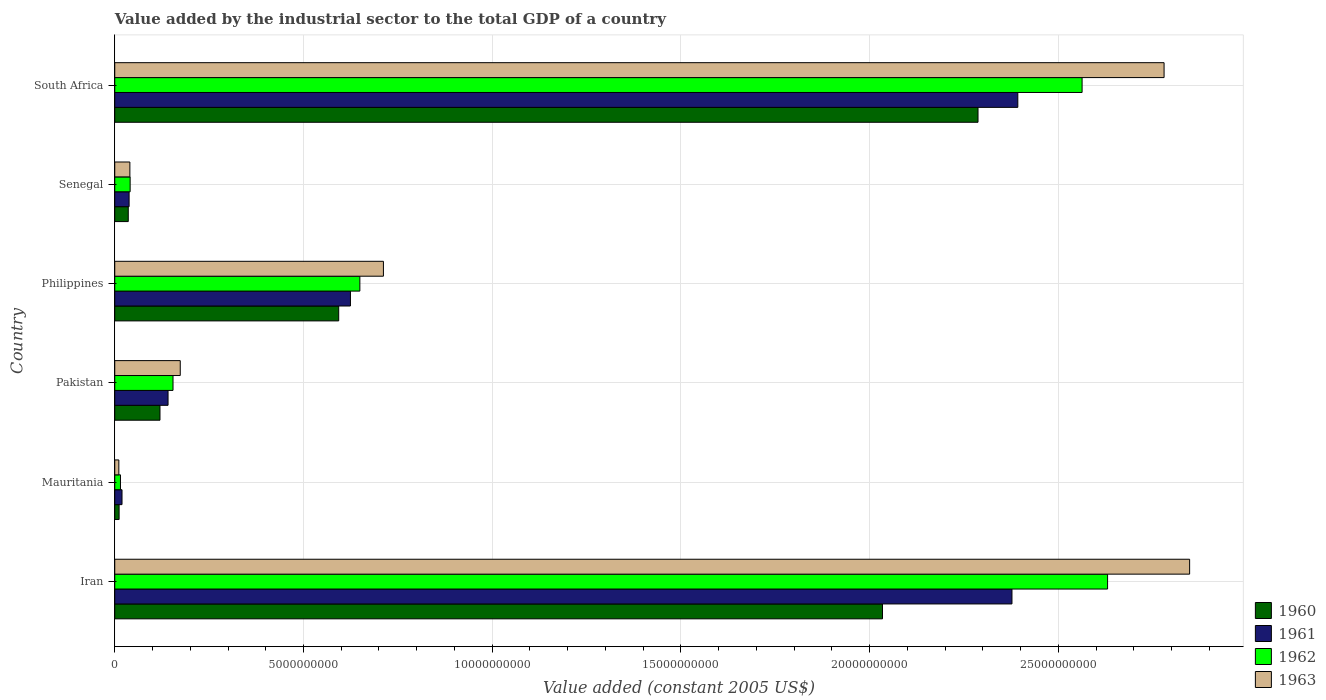How many different coloured bars are there?
Offer a terse response. 4. How many groups of bars are there?
Give a very brief answer. 6. Are the number of bars per tick equal to the number of legend labels?
Keep it short and to the point. Yes. How many bars are there on the 3rd tick from the bottom?
Your answer should be compact. 4. In how many cases, is the number of bars for a given country not equal to the number of legend labels?
Provide a succinct answer. 0. What is the value added by the industrial sector in 1962 in Philippines?
Offer a very short reply. 6.49e+09. Across all countries, what is the maximum value added by the industrial sector in 1962?
Give a very brief answer. 2.63e+1. Across all countries, what is the minimum value added by the industrial sector in 1962?
Provide a succinct answer. 1.51e+08. In which country was the value added by the industrial sector in 1963 maximum?
Offer a very short reply. Iran. In which country was the value added by the industrial sector in 1962 minimum?
Keep it short and to the point. Mauritania. What is the total value added by the industrial sector in 1961 in the graph?
Offer a very short reply. 5.59e+1. What is the difference between the value added by the industrial sector in 1962 in Senegal and that in South Africa?
Ensure brevity in your answer.  -2.52e+1. What is the difference between the value added by the industrial sector in 1960 in Mauritania and the value added by the industrial sector in 1963 in Pakistan?
Keep it short and to the point. -1.62e+09. What is the average value added by the industrial sector in 1960 per country?
Your response must be concise. 8.47e+09. What is the difference between the value added by the industrial sector in 1963 and value added by the industrial sector in 1960 in Pakistan?
Give a very brief answer. 5.37e+08. What is the ratio of the value added by the industrial sector in 1962 in Pakistan to that in Philippines?
Ensure brevity in your answer.  0.24. Is the value added by the industrial sector in 1963 in Mauritania less than that in South Africa?
Make the answer very short. Yes. What is the difference between the highest and the second highest value added by the industrial sector in 1963?
Ensure brevity in your answer.  6.77e+08. What is the difference between the highest and the lowest value added by the industrial sector in 1961?
Provide a short and direct response. 2.37e+1. In how many countries, is the value added by the industrial sector in 1961 greater than the average value added by the industrial sector in 1961 taken over all countries?
Your answer should be very brief. 2. Is it the case that in every country, the sum of the value added by the industrial sector in 1960 and value added by the industrial sector in 1961 is greater than the sum of value added by the industrial sector in 1962 and value added by the industrial sector in 1963?
Your response must be concise. No. What does the 2nd bar from the top in Senegal represents?
Ensure brevity in your answer.  1962. What does the 4th bar from the bottom in Philippines represents?
Your answer should be very brief. 1963. Is it the case that in every country, the sum of the value added by the industrial sector in 1960 and value added by the industrial sector in 1961 is greater than the value added by the industrial sector in 1963?
Your response must be concise. Yes. Are the values on the major ticks of X-axis written in scientific E-notation?
Keep it short and to the point. No. Does the graph contain any zero values?
Your answer should be very brief. No. Does the graph contain grids?
Ensure brevity in your answer.  Yes. Where does the legend appear in the graph?
Give a very brief answer. Bottom right. How many legend labels are there?
Offer a very short reply. 4. How are the legend labels stacked?
Your answer should be very brief. Vertical. What is the title of the graph?
Provide a short and direct response. Value added by the industrial sector to the total GDP of a country. What is the label or title of the X-axis?
Your answer should be compact. Value added (constant 2005 US$). What is the label or title of the Y-axis?
Offer a terse response. Country. What is the Value added (constant 2005 US$) of 1960 in Iran?
Your response must be concise. 2.03e+1. What is the Value added (constant 2005 US$) in 1961 in Iran?
Provide a succinct answer. 2.38e+1. What is the Value added (constant 2005 US$) in 1962 in Iran?
Your answer should be compact. 2.63e+1. What is the Value added (constant 2005 US$) of 1963 in Iran?
Offer a very short reply. 2.85e+1. What is the Value added (constant 2005 US$) in 1960 in Mauritania?
Your answer should be compact. 1.15e+08. What is the Value added (constant 2005 US$) in 1961 in Mauritania?
Provide a succinct answer. 1.92e+08. What is the Value added (constant 2005 US$) of 1962 in Mauritania?
Ensure brevity in your answer.  1.51e+08. What is the Value added (constant 2005 US$) of 1963 in Mauritania?
Make the answer very short. 1.08e+08. What is the Value added (constant 2005 US$) in 1960 in Pakistan?
Keep it short and to the point. 1.20e+09. What is the Value added (constant 2005 US$) in 1961 in Pakistan?
Ensure brevity in your answer.  1.41e+09. What is the Value added (constant 2005 US$) of 1962 in Pakistan?
Offer a terse response. 1.54e+09. What is the Value added (constant 2005 US$) in 1963 in Pakistan?
Offer a terse response. 1.74e+09. What is the Value added (constant 2005 US$) of 1960 in Philippines?
Offer a very short reply. 5.93e+09. What is the Value added (constant 2005 US$) in 1961 in Philippines?
Give a very brief answer. 6.24e+09. What is the Value added (constant 2005 US$) of 1962 in Philippines?
Keep it short and to the point. 6.49e+09. What is the Value added (constant 2005 US$) of 1963 in Philippines?
Provide a short and direct response. 7.12e+09. What is the Value added (constant 2005 US$) in 1960 in Senegal?
Make the answer very short. 3.58e+08. What is the Value added (constant 2005 US$) in 1961 in Senegal?
Make the answer very short. 3.80e+08. What is the Value added (constant 2005 US$) in 1962 in Senegal?
Provide a short and direct response. 4.08e+08. What is the Value added (constant 2005 US$) in 1963 in Senegal?
Your response must be concise. 4.01e+08. What is the Value added (constant 2005 US$) in 1960 in South Africa?
Your response must be concise. 2.29e+1. What is the Value added (constant 2005 US$) in 1961 in South Africa?
Provide a succinct answer. 2.39e+1. What is the Value added (constant 2005 US$) of 1962 in South Africa?
Offer a very short reply. 2.56e+1. What is the Value added (constant 2005 US$) in 1963 in South Africa?
Provide a short and direct response. 2.78e+1. Across all countries, what is the maximum Value added (constant 2005 US$) in 1960?
Provide a short and direct response. 2.29e+1. Across all countries, what is the maximum Value added (constant 2005 US$) of 1961?
Provide a succinct answer. 2.39e+1. Across all countries, what is the maximum Value added (constant 2005 US$) of 1962?
Offer a terse response. 2.63e+1. Across all countries, what is the maximum Value added (constant 2005 US$) in 1963?
Your answer should be compact. 2.85e+1. Across all countries, what is the minimum Value added (constant 2005 US$) in 1960?
Provide a short and direct response. 1.15e+08. Across all countries, what is the minimum Value added (constant 2005 US$) of 1961?
Offer a very short reply. 1.92e+08. Across all countries, what is the minimum Value added (constant 2005 US$) in 1962?
Your answer should be very brief. 1.51e+08. Across all countries, what is the minimum Value added (constant 2005 US$) in 1963?
Make the answer very short. 1.08e+08. What is the total Value added (constant 2005 US$) in 1960 in the graph?
Offer a terse response. 5.08e+1. What is the total Value added (constant 2005 US$) in 1961 in the graph?
Your response must be concise. 5.59e+1. What is the total Value added (constant 2005 US$) in 1962 in the graph?
Ensure brevity in your answer.  6.05e+1. What is the total Value added (constant 2005 US$) of 1963 in the graph?
Make the answer very short. 6.56e+1. What is the difference between the Value added (constant 2005 US$) of 1960 in Iran and that in Mauritania?
Provide a short and direct response. 2.02e+1. What is the difference between the Value added (constant 2005 US$) in 1961 in Iran and that in Mauritania?
Your answer should be compact. 2.36e+1. What is the difference between the Value added (constant 2005 US$) in 1962 in Iran and that in Mauritania?
Give a very brief answer. 2.62e+1. What is the difference between the Value added (constant 2005 US$) of 1963 in Iran and that in Mauritania?
Provide a succinct answer. 2.84e+1. What is the difference between the Value added (constant 2005 US$) in 1960 in Iran and that in Pakistan?
Give a very brief answer. 1.91e+1. What is the difference between the Value added (constant 2005 US$) in 1961 in Iran and that in Pakistan?
Offer a terse response. 2.24e+1. What is the difference between the Value added (constant 2005 US$) in 1962 in Iran and that in Pakistan?
Make the answer very short. 2.48e+1. What is the difference between the Value added (constant 2005 US$) of 1963 in Iran and that in Pakistan?
Your answer should be very brief. 2.67e+1. What is the difference between the Value added (constant 2005 US$) in 1960 in Iran and that in Philippines?
Your response must be concise. 1.44e+1. What is the difference between the Value added (constant 2005 US$) in 1961 in Iran and that in Philippines?
Give a very brief answer. 1.75e+1. What is the difference between the Value added (constant 2005 US$) of 1962 in Iran and that in Philippines?
Give a very brief answer. 1.98e+1. What is the difference between the Value added (constant 2005 US$) of 1963 in Iran and that in Philippines?
Make the answer very short. 2.14e+1. What is the difference between the Value added (constant 2005 US$) in 1960 in Iran and that in Senegal?
Your response must be concise. 2.00e+1. What is the difference between the Value added (constant 2005 US$) in 1961 in Iran and that in Senegal?
Provide a short and direct response. 2.34e+1. What is the difference between the Value added (constant 2005 US$) in 1962 in Iran and that in Senegal?
Give a very brief answer. 2.59e+1. What is the difference between the Value added (constant 2005 US$) of 1963 in Iran and that in Senegal?
Provide a short and direct response. 2.81e+1. What is the difference between the Value added (constant 2005 US$) of 1960 in Iran and that in South Africa?
Your response must be concise. -2.53e+09. What is the difference between the Value added (constant 2005 US$) of 1961 in Iran and that in South Africa?
Ensure brevity in your answer.  -1.55e+08. What is the difference between the Value added (constant 2005 US$) in 1962 in Iran and that in South Africa?
Provide a short and direct response. 6.75e+08. What is the difference between the Value added (constant 2005 US$) in 1963 in Iran and that in South Africa?
Ensure brevity in your answer.  6.77e+08. What is the difference between the Value added (constant 2005 US$) in 1960 in Mauritania and that in Pakistan?
Give a very brief answer. -1.08e+09. What is the difference between the Value added (constant 2005 US$) of 1961 in Mauritania and that in Pakistan?
Offer a very short reply. -1.22e+09. What is the difference between the Value added (constant 2005 US$) in 1962 in Mauritania and that in Pakistan?
Provide a short and direct response. -1.39e+09. What is the difference between the Value added (constant 2005 US$) of 1963 in Mauritania and that in Pakistan?
Provide a succinct answer. -1.63e+09. What is the difference between the Value added (constant 2005 US$) in 1960 in Mauritania and that in Philippines?
Give a very brief answer. -5.82e+09. What is the difference between the Value added (constant 2005 US$) in 1961 in Mauritania and that in Philippines?
Give a very brief answer. -6.05e+09. What is the difference between the Value added (constant 2005 US$) of 1962 in Mauritania and that in Philippines?
Keep it short and to the point. -6.34e+09. What is the difference between the Value added (constant 2005 US$) of 1963 in Mauritania and that in Philippines?
Provide a short and direct response. -7.01e+09. What is the difference between the Value added (constant 2005 US$) of 1960 in Mauritania and that in Senegal?
Offer a very short reply. -2.42e+08. What is the difference between the Value added (constant 2005 US$) in 1961 in Mauritania and that in Senegal?
Give a very brief answer. -1.88e+08. What is the difference between the Value added (constant 2005 US$) in 1962 in Mauritania and that in Senegal?
Offer a very short reply. -2.56e+08. What is the difference between the Value added (constant 2005 US$) of 1963 in Mauritania and that in Senegal?
Your response must be concise. -2.92e+08. What is the difference between the Value added (constant 2005 US$) in 1960 in Mauritania and that in South Africa?
Offer a very short reply. -2.28e+1. What is the difference between the Value added (constant 2005 US$) of 1961 in Mauritania and that in South Africa?
Keep it short and to the point. -2.37e+1. What is the difference between the Value added (constant 2005 US$) of 1962 in Mauritania and that in South Africa?
Your answer should be compact. -2.55e+1. What is the difference between the Value added (constant 2005 US$) in 1963 in Mauritania and that in South Africa?
Ensure brevity in your answer.  -2.77e+1. What is the difference between the Value added (constant 2005 US$) in 1960 in Pakistan and that in Philippines?
Your answer should be very brief. -4.73e+09. What is the difference between the Value added (constant 2005 US$) of 1961 in Pakistan and that in Philippines?
Give a very brief answer. -4.83e+09. What is the difference between the Value added (constant 2005 US$) of 1962 in Pakistan and that in Philippines?
Ensure brevity in your answer.  -4.95e+09. What is the difference between the Value added (constant 2005 US$) in 1963 in Pakistan and that in Philippines?
Give a very brief answer. -5.38e+09. What is the difference between the Value added (constant 2005 US$) in 1960 in Pakistan and that in Senegal?
Your answer should be compact. 8.40e+08. What is the difference between the Value added (constant 2005 US$) in 1961 in Pakistan and that in Senegal?
Your answer should be compact. 1.03e+09. What is the difference between the Value added (constant 2005 US$) in 1962 in Pakistan and that in Senegal?
Your answer should be very brief. 1.14e+09. What is the difference between the Value added (constant 2005 US$) of 1963 in Pakistan and that in Senegal?
Offer a very short reply. 1.33e+09. What is the difference between the Value added (constant 2005 US$) of 1960 in Pakistan and that in South Africa?
Offer a very short reply. -2.17e+1. What is the difference between the Value added (constant 2005 US$) in 1961 in Pakistan and that in South Africa?
Your answer should be compact. -2.25e+1. What is the difference between the Value added (constant 2005 US$) in 1962 in Pakistan and that in South Africa?
Offer a terse response. -2.41e+1. What is the difference between the Value added (constant 2005 US$) in 1963 in Pakistan and that in South Africa?
Ensure brevity in your answer.  -2.61e+1. What is the difference between the Value added (constant 2005 US$) of 1960 in Philippines and that in Senegal?
Give a very brief answer. 5.57e+09. What is the difference between the Value added (constant 2005 US$) of 1961 in Philippines and that in Senegal?
Make the answer very short. 5.86e+09. What is the difference between the Value added (constant 2005 US$) of 1962 in Philippines and that in Senegal?
Your response must be concise. 6.09e+09. What is the difference between the Value added (constant 2005 US$) of 1963 in Philippines and that in Senegal?
Your response must be concise. 6.72e+09. What is the difference between the Value added (constant 2005 US$) of 1960 in Philippines and that in South Africa?
Your answer should be very brief. -1.69e+1. What is the difference between the Value added (constant 2005 US$) of 1961 in Philippines and that in South Africa?
Give a very brief answer. -1.77e+1. What is the difference between the Value added (constant 2005 US$) of 1962 in Philippines and that in South Africa?
Give a very brief answer. -1.91e+1. What is the difference between the Value added (constant 2005 US$) of 1963 in Philippines and that in South Africa?
Provide a succinct answer. -2.07e+1. What is the difference between the Value added (constant 2005 US$) in 1960 in Senegal and that in South Africa?
Give a very brief answer. -2.25e+1. What is the difference between the Value added (constant 2005 US$) in 1961 in Senegal and that in South Africa?
Make the answer very short. -2.35e+1. What is the difference between the Value added (constant 2005 US$) in 1962 in Senegal and that in South Africa?
Your answer should be compact. -2.52e+1. What is the difference between the Value added (constant 2005 US$) in 1963 in Senegal and that in South Africa?
Your answer should be very brief. -2.74e+1. What is the difference between the Value added (constant 2005 US$) in 1960 in Iran and the Value added (constant 2005 US$) in 1961 in Mauritania?
Keep it short and to the point. 2.01e+1. What is the difference between the Value added (constant 2005 US$) of 1960 in Iran and the Value added (constant 2005 US$) of 1962 in Mauritania?
Make the answer very short. 2.02e+1. What is the difference between the Value added (constant 2005 US$) in 1960 in Iran and the Value added (constant 2005 US$) in 1963 in Mauritania?
Make the answer very short. 2.02e+1. What is the difference between the Value added (constant 2005 US$) of 1961 in Iran and the Value added (constant 2005 US$) of 1962 in Mauritania?
Ensure brevity in your answer.  2.36e+1. What is the difference between the Value added (constant 2005 US$) in 1961 in Iran and the Value added (constant 2005 US$) in 1963 in Mauritania?
Make the answer very short. 2.37e+1. What is the difference between the Value added (constant 2005 US$) in 1962 in Iran and the Value added (constant 2005 US$) in 1963 in Mauritania?
Make the answer very short. 2.62e+1. What is the difference between the Value added (constant 2005 US$) in 1960 in Iran and the Value added (constant 2005 US$) in 1961 in Pakistan?
Make the answer very short. 1.89e+1. What is the difference between the Value added (constant 2005 US$) of 1960 in Iran and the Value added (constant 2005 US$) of 1962 in Pakistan?
Your answer should be very brief. 1.88e+1. What is the difference between the Value added (constant 2005 US$) of 1960 in Iran and the Value added (constant 2005 US$) of 1963 in Pakistan?
Provide a short and direct response. 1.86e+1. What is the difference between the Value added (constant 2005 US$) in 1961 in Iran and the Value added (constant 2005 US$) in 1962 in Pakistan?
Your answer should be very brief. 2.22e+1. What is the difference between the Value added (constant 2005 US$) in 1961 in Iran and the Value added (constant 2005 US$) in 1963 in Pakistan?
Provide a short and direct response. 2.20e+1. What is the difference between the Value added (constant 2005 US$) of 1962 in Iran and the Value added (constant 2005 US$) of 1963 in Pakistan?
Provide a short and direct response. 2.46e+1. What is the difference between the Value added (constant 2005 US$) of 1960 in Iran and the Value added (constant 2005 US$) of 1961 in Philippines?
Provide a short and direct response. 1.41e+1. What is the difference between the Value added (constant 2005 US$) in 1960 in Iran and the Value added (constant 2005 US$) in 1962 in Philippines?
Offer a terse response. 1.38e+1. What is the difference between the Value added (constant 2005 US$) of 1960 in Iran and the Value added (constant 2005 US$) of 1963 in Philippines?
Offer a very short reply. 1.32e+1. What is the difference between the Value added (constant 2005 US$) in 1961 in Iran and the Value added (constant 2005 US$) in 1962 in Philippines?
Your answer should be very brief. 1.73e+1. What is the difference between the Value added (constant 2005 US$) of 1961 in Iran and the Value added (constant 2005 US$) of 1963 in Philippines?
Offer a terse response. 1.67e+1. What is the difference between the Value added (constant 2005 US$) of 1962 in Iran and the Value added (constant 2005 US$) of 1963 in Philippines?
Provide a short and direct response. 1.92e+1. What is the difference between the Value added (constant 2005 US$) in 1960 in Iran and the Value added (constant 2005 US$) in 1961 in Senegal?
Your answer should be very brief. 2.00e+1. What is the difference between the Value added (constant 2005 US$) in 1960 in Iran and the Value added (constant 2005 US$) in 1962 in Senegal?
Make the answer very short. 1.99e+1. What is the difference between the Value added (constant 2005 US$) of 1960 in Iran and the Value added (constant 2005 US$) of 1963 in Senegal?
Offer a terse response. 1.99e+1. What is the difference between the Value added (constant 2005 US$) in 1961 in Iran and the Value added (constant 2005 US$) in 1962 in Senegal?
Your answer should be very brief. 2.34e+1. What is the difference between the Value added (constant 2005 US$) in 1961 in Iran and the Value added (constant 2005 US$) in 1963 in Senegal?
Offer a terse response. 2.34e+1. What is the difference between the Value added (constant 2005 US$) in 1962 in Iran and the Value added (constant 2005 US$) in 1963 in Senegal?
Your answer should be compact. 2.59e+1. What is the difference between the Value added (constant 2005 US$) in 1960 in Iran and the Value added (constant 2005 US$) in 1961 in South Africa?
Your answer should be very brief. -3.58e+09. What is the difference between the Value added (constant 2005 US$) of 1960 in Iran and the Value added (constant 2005 US$) of 1962 in South Africa?
Ensure brevity in your answer.  -5.29e+09. What is the difference between the Value added (constant 2005 US$) of 1960 in Iran and the Value added (constant 2005 US$) of 1963 in South Africa?
Offer a very short reply. -7.46e+09. What is the difference between the Value added (constant 2005 US$) of 1961 in Iran and the Value added (constant 2005 US$) of 1962 in South Africa?
Provide a succinct answer. -1.86e+09. What is the difference between the Value added (constant 2005 US$) of 1961 in Iran and the Value added (constant 2005 US$) of 1963 in South Africa?
Your answer should be compact. -4.03e+09. What is the difference between the Value added (constant 2005 US$) of 1962 in Iran and the Value added (constant 2005 US$) of 1963 in South Africa?
Keep it short and to the point. -1.50e+09. What is the difference between the Value added (constant 2005 US$) of 1960 in Mauritania and the Value added (constant 2005 US$) of 1961 in Pakistan?
Provide a short and direct response. -1.30e+09. What is the difference between the Value added (constant 2005 US$) of 1960 in Mauritania and the Value added (constant 2005 US$) of 1962 in Pakistan?
Provide a short and direct response. -1.43e+09. What is the difference between the Value added (constant 2005 US$) of 1960 in Mauritania and the Value added (constant 2005 US$) of 1963 in Pakistan?
Your answer should be compact. -1.62e+09. What is the difference between the Value added (constant 2005 US$) in 1961 in Mauritania and the Value added (constant 2005 US$) in 1962 in Pakistan?
Make the answer very short. -1.35e+09. What is the difference between the Value added (constant 2005 US$) of 1961 in Mauritania and the Value added (constant 2005 US$) of 1963 in Pakistan?
Your answer should be very brief. -1.54e+09. What is the difference between the Value added (constant 2005 US$) in 1962 in Mauritania and the Value added (constant 2005 US$) in 1963 in Pakistan?
Your answer should be very brief. -1.58e+09. What is the difference between the Value added (constant 2005 US$) of 1960 in Mauritania and the Value added (constant 2005 US$) of 1961 in Philippines?
Your answer should be compact. -6.13e+09. What is the difference between the Value added (constant 2005 US$) of 1960 in Mauritania and the Value added (constant 2005 US$) of 1962 in Philippines?
Your answer should be very brief. -6.38e+09. What is the difference between the Value added (constant 2005 US$) in 1960 in Mauritania and the Value added (constant 2005 US$) in 1963 in Philippines?
Offer a terse response. -7.00e+09. What is the difference between the Value added (constant 2005 US$) of 1961 in Mauritania and the Value added (constant 2005 US$) of 1962 in Philippines?
Ensure brevity in your answer.  -6.30e+09. What is the difference between the Value added (constant 2005 US$) in 1961 in Mauritania and the Value added (constant 2005 US$) in 1963 in Philippines?
Make the answer very short. -6.93e+09. What is the difference between the Value added (constant 2005 US$) in 1962 in Mauritania and the Value added (constant 2005 US$) in 1963 in Philippines?
Provide a short and direct response. -6.97e+09. What is the difference between the Value added (constant 2005 US$) in 1960 in Mauritania and the Value added (constant 2005 US$) in 1961 in Senegal?
Provide a short and direct response. -2.65e+08. What is the difference between the Value added (constant 2005 US$) of 1960 in Mauritania and the Value added (constant 2005 US$) of 1962 in Senegal?
Ensure brevity in your answer.  -2.92e+08. What is the difference between the Value added (constant 2005 US$) of 1960 in Mauritania and the Value added (constant 2005 US$) of 1963 in Senegal?
Offer a very short reply. -2.85e+08. What is the difference between the Value added (constant 2005 US$) in 1961 in Mauritania and the Value added (constant 2005 US$) in 1962 in Senegal?
Your answer should be very brief. -2.15e+08. What is the difference between the Value added (constant 2005 US$) of 1961 in Mauritania and the Value added (constant 2005 US$) of 1963 in Senegal?
Your answer should be compact. -2.08e+08. What is the difference between the Value added (constant 2005 US$) of 1962 in Mauritania and the Value added (constant 2005 US$) of 1963 in Senegal?
Provide a short and direct response. -2.49e+08. What is the difference between the Value added (constant 2005 US$) in 1960 in Mauritania and the Value added (constant 2005 US$) in 1961 in South Africa?
Offer a terse response. -2.38e+1. What is the difference between the Value added (constant 2005 US$) in 1960 in Mauritania and the Value added (constant 2005 US$) in 1962 in South Africa?
Ensure brevity in your answer.  -2.55e+1. What is the difference between the Value added (constant 2005 US$) of 1960 in Mauritania and the Value added (constant 2005 US$) of 1963 in South Africa?
Your answer should be compact. -2.77e+1. What is the difference between the Value added (constant 2005 US$) in 1961 in Mauritania and the Value added (constant 2005 US$) in 1962 in South Africa?
Keep it short and to the point. -2.54e+1. What is the difference between the Value added (constant 2005 US$) of 1961 in Mauritania and the Value added (constant 2005 US$) of 1963 in South Africa?
Make the answer very short. -2.76e+1. What is the difference between the Value added (constant 2005 US$) in 1962 in Mauritania and the Value added (constant 2005 US$) in 1963 in South Africa?
Ensure brevity in your answer.  -2.76e+1. What is the difference between the Value added (constant 2005 US$) of 1960 in Pakistan and the Value added (constant 2005 US$) of 1961 in Philippines?
Ensure brevity in your answer.  -5.05e+09. What is the difference between the Value added (constant 2005 US$) of 1960 in Pakistan and the Value added (constant 2005 US$) of 1962 in Philippines?
Ensure brevity in your answer.  -5.30e+09. What is the difference between the Value added (constant 2005 US$) of 1960 in Pakistan and the Value added (constant 2005 US$) of 1963 in Philippines?
Offer a very short reply. -5.92e+09. What is the difference between the Value added (constant 2005 US$) in 1961 in Pakistan and the Value added (constant 2005 US$) in 1962 in Philippines?
Make the answer very short. -5.08e+09. What is the difference between the Value added (constant 2005 US$) of 1961 in Pakistan and the Value added (constant 2005 US$) of 1963 in Philippines?
Provide a succinct answer. -5.71e+09. What is the difference between the Value added (constant 2005 US$) of 1962 in Pakistan and the Value added (constant 2005 US$) of 1963 in Philippines?
Your answer should be very brief. -5.57e+09. What is the difference between the Value added (constant 2005 US$) of 1960 in Pakistan and the Value added (constant 2005 US$) of 1961 in Senegal?
Your answer should be very brief. 8.18e+08. What is the difference between the Value added (constant 2005 US$) in 1960 in Pakistan and the Value added (constant 2005 US$) in 1962 in Senegal?
Give a very brief answer. 7.91e+08. What is the difference between the Value added (constant 2005 US$) of 1960 in Pakistan and the Value added (constant 2005 US$) of 1963 in Senegal?
Give a very brief answer. 7.98e+08. What is the difference between the Value added (constant 2005 US$) in 1961 in Pakistan and the Value added (constant 2005 US$) in 1962 in Senegal?
Make the answer very short. 1.00e+09. What is the difference between the Value added (constant 2005 US$) of 1961 in Pakistan and the Value added (constant 2005 US$) of 1963 in Senegal?
Keep it short and to the point. 1.01e+09. What is the difference between the Value added (constant 2005 US$) of 1962 in Pakistan and the Value added (constant 2005 US$) of 1963 in Senegal?
Your answer should be very brief. 1.14e+09. What is the difference between the Value added (constant 2005 US$) of 1960 in Pakistan and the Value added (constant 2005 US$) of 1961 in South Africa?
Offer a very short reply. -2.27e+1. What is the difference between the Value added (constant 2005 US$) in 1960 in Pakistan and the Value added (constant 2005 US$) in 1962 in South Africa?
Give a very brief answer. -2.44e+1. What is the difference between the Value added (constant 2005 US$) of 1960 in Pakistan and the Value added (constant 2005 US$) of 1963 in South Africa?
Provide a succinct answer. -2.66e+1. What is the difference between the Value added (constant 2005 US$) of 1961 in Pakistan and the Value added (constant 2005 US$) of 1962 in South Africa?
Your answer should be very brief. -2.42e+1. What is the difference between the Value added (constant 2005 US$) of 1961 in Pakistan and the Value added (constant 2005 US$) of 1963 in South Africa?
Your answer should be very brief. -2.64e+1. What is the difference between the Value added (constant 2005 US$) in 1962 in Pakistan and the Value added (constant 2005 US$) in 1963 in South Africa?
Offer a very short reply. -2.63e+1. What is the difference between the Value added (constant 2005 US$) in 1960 in Philippines and the Value added (constant 2005 US$) in 1961 in Senegal?
Make the answer very short. 5.55e+09. What is the difference between the Value added (constant 2005 US$) of 1960 in Philippines and the Value added (constant 2005 US$) of 1962 in Senegal?
Keep it short and to the point. 5.53e+09. What is the difference between the Value added (constant 2005 US$) of 1960 in Philippines and the Value added (constant 2005 US$) of 1963 in Senegal?
Make the answer very short. 5.53e+09. What is the difference between the Value added (constant 2005 US$) in 1961 in Philippines and the Value added (constant 2005 US$) in 1962 in Senegal?
Your answer should be very brief. 5.84e+09. What is the difference between the Value added (constant 2005 US$) in 1961 in Philippines and the Value added (constant 2005 US$) in 1963 in Senegal?
Make the answer very short. 5.84e+09. What is the difference between the Value added (constant 2005 US$) of 1962 in Philippines and the Value added (constant 2005 US$) of 1963 in Senegal?
Keep it short and to the point. 6.09e+09. What is the difference between the Value added (constant 2005 US$) in 1960 in Philippines and the Value added (constant 2005 US$) in 1961 in South Africa?
Your response must be concise. -1.80e+1. What is the difference between the Value added (constant 2005 US$) of 1960 in Philippines and the Value added (constant 2005 US$) of 1962 in South Africa?
Make the answer very short. -1.97e+1. What is the difference between the Value added (constant 2005 US$) in 1960 in Philippines and the Value added (constant 2005 US$) in 1963 in South Africa?
Provide a succinct answer. -2.19e+1. What is the difference between the Value added (constant 2005 US$) in 1961 in Philippines and the Value added (constant 2005 US$) in 1962 in South Africa?
Offer a very short reply. -1.94e+1. What is the difference between the Value added (constant 2005 US$) in 1961 in Philippines and the Value added (constant 2005 US$) in 1963 in South Africa?
Give a very brief answer. -2.16e+1. What is the difference between the Value added (constant 2005 US$) of 1962 in Philippines and the Value added (constant 2005 US$) of 1963 in South Africa?
Provide a succinct answer. -2.13e+1. What is the difference between the Value added (constant 2005 US$) in 1960 in Senegal and the Value added (constant 2005 US$) in 1961 in South Africa?
Offer a very short reply. -2.36e+1. What is the difference between the Value added (constant 2005 US$) in 1960 in Senegal and the Value added (constant 2005 US$) in 1962 in South Africa?
Your answer should be very brief. -2.53e+1. What is the difference between the Value added (constant 2005 US$) in 1960 in Senegal and the Value added (constant 2005 US$) in 1963 in South Africa?
Offer a terse response. -2.74e+1. What is the difference between the Value added (constant 2005 US$) in 1961 in Senegal and the Value added (constant 2005 US$) in 1962 in South Africa?
Give a very brief answer. -2.52e+1. What is the difference between the Value added (constant 2005 US$) of 1961 in Senegal and the Value added (constant 2005 US$) of 1963 in South Africa?
Offer a very short reply. -2.74e+1. What is the difference between the Value added (constant 2005 US$) in 1962 in Senegal and the Value added (constant 2005 US$) in 1963 in South Africa?
Offer a terse response. -2.74e+1. What is the average Value added (constant 2005 US$) in 1960 per country?
Offer a terse response. 8.47e+09. What is the average Value added (constant 2005 US$) in 1961 per country?
Ensure brevity in your answer.  9.32e+09. What is the average Value added (constant 2005 US$) in 1962 per country?
Keep it short and to the point. 1.01e+1. What is the average Value added (constant 2005 US$) in 1963 per country?
Give a very brief answer. 1.09e+1. What is the difference between the Value added (constant 2005 US$) in 1960 and Value added (constant 2005 US$) in 1961 in Iran?
Provide a short and direct response. -3.43e+09. What is the difference between the Value added (constant 2005 US$) of 1960 and Value added (constant 2005 US$) of 1962 in Iran?
Keep it short and to the point. -5.96e+09. What is the difference between the Value added (constant 2005 US$) of 1960 and Value added (constant 2005 US$) of 1963 in Iran?
Offer a very short reply. -8.14e+09. What is the difference between the Value added (constant 2005 US$) of 1961 and Value added (constant 2005 US$) of 1962 in Iran?
Offer a terse response. -2.53e+09. What is the difference between the Value added (constant 2005 US$) in 1961 and Value added (constant 2005 US$) in 1963 in Iran?
Offer a very short reply. -4.71e+09. What is the difference between the Value added (constant 2005 US$) of 1962 and Value added (constant 2005 US$) of 1963 in Iran?
Provide a succinct answer. -2.17e+09. What is the difference between the Value added (constant 2005 US$) in 1960 and Value added (constant 2005 US$) in 1961 in Mauritania?
Your answer should be compact. -7.68e+07. What is the difference between the Value added (constant 2005 US$) in 1960 and Value added (constant 2005 US$) in 1962 in Mauritania?
Your answer should be very brief. -3.59e+07. What is the difference between the Value added (constant 2005 US$) of 1960 and Value added (constant 2005 US$) of 1963 in Mauritania?
Make the answer very short. 7.13e+06. What is the difference between the Value added (constant 2005 US$) of 1961 and Value added (constant 2005 US$) of 1962 in Mauritania?
Keep it short and to the point. 4.09e+07. What is the difference between the Value added (constant 2005 US$) in 1961 and Value added (constant 2005 US$) in 1963 in Mauritania?
Offer a very short reply. 8.39e+07. What is the difference between the Value added (constant 2005 US$) in 1962 and Value added (constant 2005 US$) in 1963 in Mauritania?
Make the answer very short. 4.31e+07. What is the difference between the Value added (constant 2005 US$) in 1960 and Value added (constant 2005 US$) in 1961 in Pakistan?
Provide a short and direct response. -2.14e+08. What is the difference between the Value added (constant 2005 US$) in 1960 and Value added (constant 2005 US$) in 1962 in Pakistan?
Provide a short and direct response. -3.45e+08. What is the difference between the Value added (constant 2005 US$) of 1960 and Value added (constant 2005 US$) of 1963 in Pakistan?
Your response must be concise. -5.37e+08. What is the difference between the Value added (constant 2005 US$) in 1961 and Value added (constant 2005 US$) in 1962 in Pakistan?
Provide a short and direct response. -1.32e+08. What is the difference between the Value added (constant 2005 US$) in 1961 and Value added (constant 2005 US$) in 1963 in Pakistan?
Your answer should be very brief. -3.23e+08. What is the difference between the Value added (constant 2005 US$) in 1962 and Value added (constant 2005 US$) in 1963 in Pakistan?
Offer a terse response. -1.92e+08. What is the difference between the Value added (constant 2005 US$) in 1960 and Value added (constant 2005 US$) in 1961 in Philippines?
Offer a terse response. -3.11e+08. What is the difference between the Value added (constant 2005 US$) in 1960 and Value added (constant 2005 US$) in 1962 in Philippines?
Your answer should be very brief. -5.61e+08. What is the difference between the Value added (constant 2005 US$) of 1960 and Value added (constant 2005 US$) of 1963 in Philippines?
Keep it short and to the point. -1.18e+09. What is the difference between the Value added (constant 2005 US$) of 1961 and Value added (constant 2005 US$) of 1962 in Philippines?
Provide a short and direct response. -2.50e+08. What is the difference between the Value added (constant 2005 US$) in 1961 and Value added (constant 2005 US$) in 1963 in Philippines?
Offer a terse response. -8.74e+08. What is the difference between the Value added (constant 2005 US$) of 1962 and Value added (constant 2005 US$) of 1963 in Philippines?
Provide a succinct answer. -6.24e+08. What is the difference between the Value added (constant 2005 US$) in 1960 and Value added (constant 2005 US$) in 1961 in Senegal?
Your answer should be very brief. -2.25e+07. What is the difference between the Value added (constant 2005 US$) of 1960 and Value added (constant 2005 US$) of 1962 in Senegal?
Keep it short and to the point. -4.98e+07. What is the difference between the Value added (constant 2005 US$) of 1960 and Value added (constant 2005 US$) of 1963 in Senegal?
Provide a succinct answer. -4.27e+07. What is the difference between the Value added (constant 2005 US$) of 1961 and Value added (constant 2005 US$) of 1962 in Senegal?
Provide a short and direct response. -2.72e+07. What is the difference between the Value added (constant 2005 US$) in 1961 and Value added (constant 2005 US$) in 1963 in Senegal?
Your answer should be very brief. -2.02e+07. What is the difference between the Value added (constant 2005 US$) of 1962 and Value added (constant 2005 US$) of 1963 in Senegal?
Keep it short and to the point. 7.03e+06. What is the difference between the Value added (constant 2005 US$) of 1960 and Value added (constant 2005 US$) of 1961 in South Africa?
Provide a succinct answer. -1.05e+09. What is the difference between the Value added (constant 2005 US$) in 1960 and Value added (constant 2005 US$) in 1962 in South Africa?
Make the answer very short. -2.76e+09. What is the difference between the Value added (constant 2005 US$) in 1960 and Value added (constant 2005 US$) in 1963 in South Africa?
Your response must be concise. -4.93e+09. What is the difference between the Value added (constant 2005 US$) of 1961 and Value added (constant 2005 US$) of 1962 in South Africa?
Your answer should be compact. -1.70e+09. What is the difference between the Value added (constant 2005 US$) in 1961 and Value added (constant 2005 US$) in 1963 in South Africa?
Your answer should be compact. -3.87e+09. What is the difference between the Value added (constant 2005 US$) of 1962 and Value added (constant 2005 US$) of 1963 in South Africa?
Keep it short and to the point. -2.17e+09. What is the ratio of the Value added (constant 2005 US$) in 1960 in Iran to that in Mauritania?
Give a very brief answer. 176.32. What is the ratio of the Value added (constant 2005 US$) in 1961 in Iran to that in Mauritania?
Offer a very short reply. 123.7. What is the ratio of the Value added (constant 2005 US$) in 1962 in Iran to that in Mauritania?
Your answer should be compact. 173.84. What is the ratio of the Value added (constant 2005 US$) of 1963 in Iran to that in Mauritania?
Your answer should be compact. 263.11. What is the ratio of the Value added (constant 2005 US$) in 1960 in Iran to that in Pakistan?
Keep it short and to the point. 16.98. What is the ratio of the Value added (constant 2005 US$) of 1961 in Iran to that in Pakistan?
Keep it short and to the point. 16.84. What is the ratio of the Value added (constant 2005 US$) of 1962 in Iran to that in Pakistan?
Give a very brief answer. 17.04. What is the ratio of the Value added (constant 2005 US$) in 1963 in Iran to that in Pakistan?
Offer a terse response. 16.41. What is the ratio of the Value added (constant 2005 US$) in 1960 in Iran to that in Philippines?
Provide a short and direct response. 3.43. What is the ratio of the Value added (constant 2005 US$) in 1961 in Iran to that in Philippines?
Give a very brief answer. 3.81. What is the ratio of the Value added (constant 2005 US$) of 1962 in Iran to that in Philippines?
Keep it short and to the point. 4.05. What is the ratio of the Value added (constant 2005 US$) of 1963 in Iran to that in Philippines?
Give a very brief answer. 4. What is the ratio of the Value added (constant 2005 US$) in 1960 in Iran to that in Senegal?
Offer a very short reply. 56.85. What is the ratio of the Value added (constant 2005 US$) in 1961 in Iran to that in Senegal?
Give a very brief answer. 62.5. What is the ratio of the Value added (constant 2005 US$) in 1962 in Iran to that in Senegal?
Give a very brief answer. 64.54. What is the ratio of the Value added (constant 2005 US$) in 1963 in Iran to that in Senegal?
Provide a short and direct response. 71.1. What is the ratio of the Value added (constant 2005 US$) in 1960 in Iran to that in South Africa?
Give a very brief answer. 0.89. What is the ratio of the Value added (constant 2005 US$) in 1961 in Iran to that in South Africa?
Your response must be concise. 0.99. What is the ratio of the Value added (constant 2005 US$) in 1962 in Iran to that in South Africa?
Keep it short and to the point. 1.03. What is the ratio of the Value added (constant 2005 US$) in 1963 in Iran to that in South Africa?
Your answer should be very brief. 1.02. What is the ratio of the Value added (constant 2005 US$) in 1960 in Mauritania to that in Pakistan?
Your answer should be compact. 0.1. What is the ratio of the Value added (constant 2005 US$) in 1961 in Mauritania to that in Pakistan?
Your answer should be very brief. 0.14. What is the ratio of the Value added (constant 2005 US$) in 1962 in Mauritania to that in Pakistan?
Offer a very short reply. 0.1. What is the ratio of the Value added (constant 2005 US$) of 1963 in Mauritania to that in Pakistan?
Ensure brevity in your answer.  0.06. What is the ratio of the Value added (constant 2005 US$) of 1960 in Mauritania to that in Philippines?
Offer a terse response. 0.02. What is the ratio of the Value added (constant 2005 US$) in 1961 in Mauritania to that in Philippines?
Provide a short and direct response. 0.03. What is the ratio of the Value added (constant 2005 US$) of 1962 in Mauritania to that in Philippines?
Offer a very short reply. 0.02. What is the ratio of the Value added (constant 2005 US$) of 1963 in Mauritania to that in Philippines?
Keep it short and to the point. 0.02. What is the ratio of the Value added (constant 2005 US$) of 1960 in Mauritania to that in Senegal?
Keep it short and to the point. 0.32. What is the ratio of the Value added (constant 2005 US$) in 1961 in Mauritania to that in Senegal?
Provide a short and direct response. 0.51. What is the ratio of the Value added (constant 2005 US$) of 1962 in Mauritania to that in Senegal?
Make the answer very short. 0.37. What is the ratio of the Value added (constant 2005 US$) in 1963 in Mauritania to that in Senegal?
Keep it short and to the point. 0.27. What is the ratio of the Value added (constant 2005 US$) in 1960 in Mauritania to that in South Africa?
Provide a short and direct response. 0.01. What is the ratio of the Value added (constant 2005 US$) in 1961 in Mauritania to that in South Africa?
Your answer should be compact. 0.01. What is the ratio of the Value added (constant 2005 US$) in 1962 in Mauritania to that in South Africa?
Keep it short and to the point. 0.01. What is the ratio of the Value added (constant 2005 US$) in 1963 in Mauritania to that in South Africa?
Give a very brief answer. 0. What is the ratio of the Value added (constant 2005 US$) in 1960 in Pakistan to that in Philippines?
Your response must be concise. 0.2. What is the ratio of the Value added (constant 2005 US$) in 1961 in Pakistan to that in Philippines?
Keep it short and to the point. 0.23. What is the ratio of the Value added (constant 2005 US$) of 1962 in Pakistan to that in Philippines?
Your answer should be very brief. 0.24. What is the ratio of the Value added (constant 2005 US$) in 1963 in Pakistan to that in Philippines?
Your answer should be compact. 0.24. What is the ratio of the Value added (constant 2005 US$) of 1960 in Pakistan to that in Senegal?
Give a very brief answer. 3.35. What is the ratio of the Value added (constant 2005 US$) of 1961 in Pakistan to that in Senegal?
Your response must be concise. 3.71. What is the ratio of the Value added (constant 2005 US$) of 1962 in Pakistan to that in Senegal?
Your answer should be compact. 3.79. What is the ratio of the Value added (constant 2005 US$) of 1963 in Pakistan to that in Senegal?
Keep it short and to the point. 4.33. What is the ratio of the Value added (constant 2005 US$) of 1960 in Pakistan to that in South Africa?
Provide a succinct answer. 0.05. What is the ratio of the Value added (constant 2005 US$) of 1961 in Pakistan to that in South Africa?
Provide a short and direct response. 0.06. What is the ratio of the Value added (constant 2005 US$) in 1962 in Pakistan to that in South Africa?
Give a very brief answer. 0.06. What is the ratio of the Value added (constant 2005 US$) in 1963 in Pakistan to that in South Africa?
Your response must be concise. 0.06. What is the ratio of the Value added (constant 2005 US$) in 1960 in Philippines to that in Senegal?
Your answer should be compact. 16.58. What is the ratio of the Value added (constant 2005 US$) of 1961 in Philippines to that in Senegal?
Make the answer very short. 16.42. What is the ratio of the Value added (constant 2005 US$) in 1962 in Philippines to that in Senegal?
Offer a terse response. 15.93. What is the ratio of the Value added (constant 2005 US$) of 1963 in Philippines to that in Senegal?
Your response must be concise. 17.77. What is the ratio of the Value added (constant 2005 US$) in 1960 in Philippines to that in South Africa?
Your answer should be compact. 0.26. What is the ratio of the Value added (constant 2005 US$) of 1961 in Philippines to that in South Africa?
Provide a succinct answer. 0.26. What is the ratio of the Value added (constant 2005 US$) of 1962 in Philippines to that in South Africa?
Provide a succinct answer. 0.25. What is the ratio of the Value added (constant 2005 US$) of 1963 in Philippines to that in South Africa?
Give a very brief answer. 0.26. What is the ratio of the Value added (constant 2005 US$) in 1960 in Senegal to that in South Africa?
Offer a terse response. 0.02. What is the ratio of the Value added (constant 2005 US$) in 1961 in Senegal to that in South Africa?
Provide a short and direct response. 0.02. What is the ratio of the Value added (constant 2005 US$) of 1962 in Senegal to that in South Africa?
Provide a short and direct response. 0.02. What is the ratio of the Value added (constant 2005 US$) of 1963 in Senegal to that in South Africa?
Provide a succinct answer. 0.01. What is the difference between the highest and the second highest Value added (constant 2005 US$) in 1960?
Your answer should be compact. 2.53e+09. What is the difference between the highest and the second highest Value added (constant 2005 US$) of 1961?
Your response must be concise. 1.55e+08. What is the difference between the highest and the second highest Value added (constant 2005 US$) in 1962?
Keep it short and to the point. 6.75e+08. What is the difference between the highest and the second highest Value added (constant 2005 US$) of 1963?
Offer a very short reply. 6.77e+08. What is the difference between the highest and the lowest Value added (constant 2005 US$) of 1960?
Make the answer very short. 2.28e+1. What is the difference between the highest and the lowest Value added (constant 2005 US$) in 1961?
Ensure brevity in your answer.  2.37e+1. What is the difference between the highest and the lowest Value added (constant 2005 US$) of 1962?
Your answer should be very brief. 2.62e+1. What is the difference between the highest and the lowest Value added (constant 2005 US$) of 1963?
Your response must be concise. 2.84e+1. 